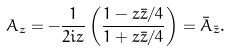Convert formula to latex. <formula><loc_0><loc_0><loc_500><loc_500>A _ { z } = - \frac { 1 } { 2 i z } \left ( \frac { 1 - z \bar { z } / 4 } { 1 + z \bar { z } / 4 } \right ) = \bar { A } _ { \bar { z } } .</formula> 